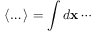<formula> <loc_0><loc_0><loc_500><loc_500>\langle \dots \rangle = \int d x \cdots</formula> 